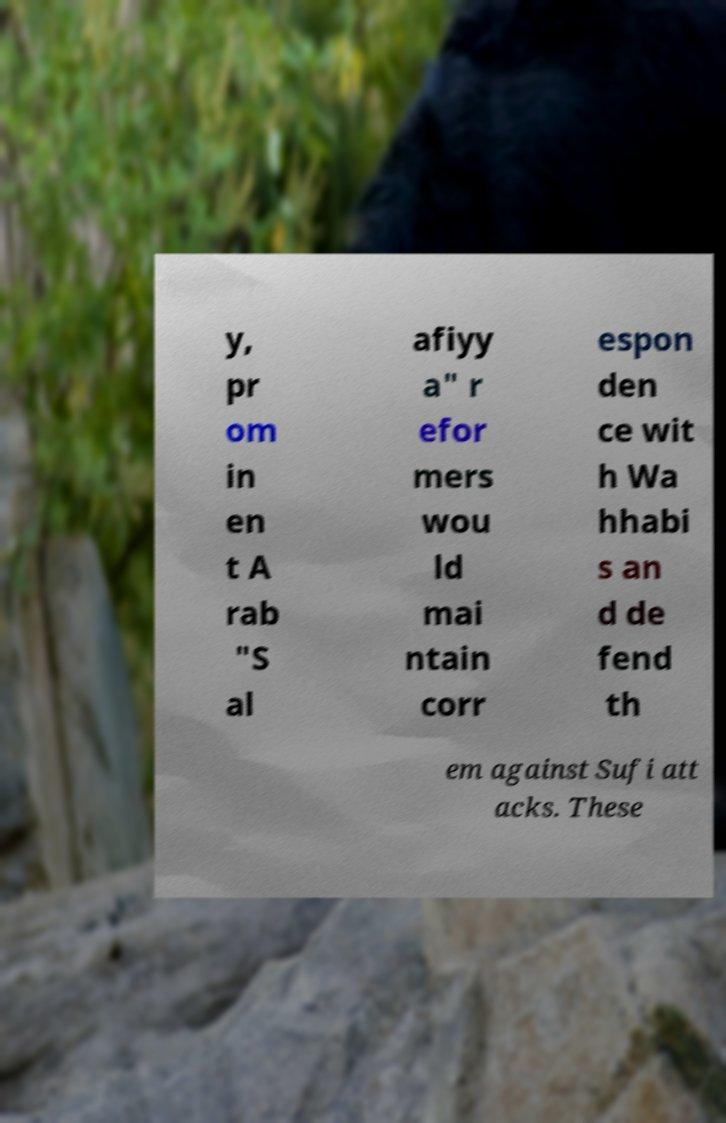I need the written content from this picture converted into text. Can you do that? y, pr om in en t A rab "S al afiyy a" r efor mers wou ld mai ntain corr espon den ce wit h Wa hhabi s an d de fend th em against Sufi att acks. These 